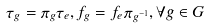Convert formula to latex. <formula><loc_0><loc_0><loc_500><loc_500>\tau _ { g } = \pi _ { g } \tau _ { e } , f _ { g } = f _ { e } \pi _ { g ^ { - 1 } } , \forall g \in G</formula> 